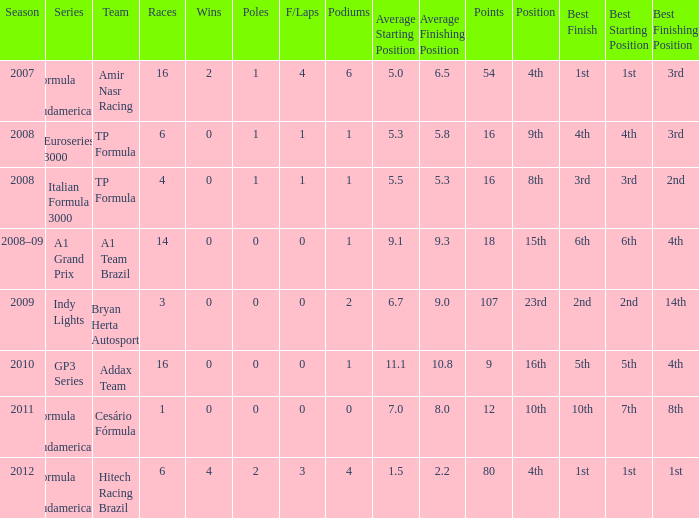In the race where he surpassed 1.0 poles, how many points did he earn? 80.0. 